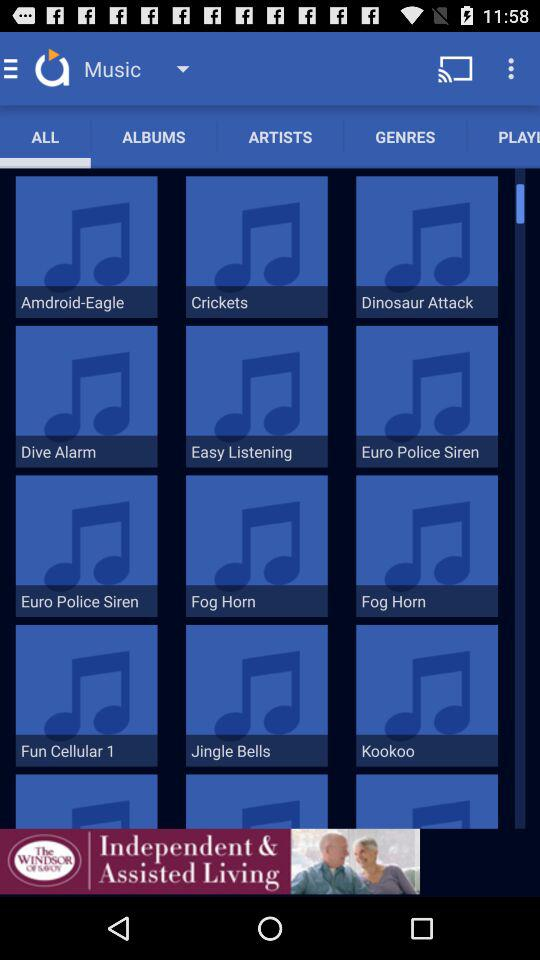How many items are in the third row that have a blue background with a music note?
Answer the question using a single word or phrase. 3 